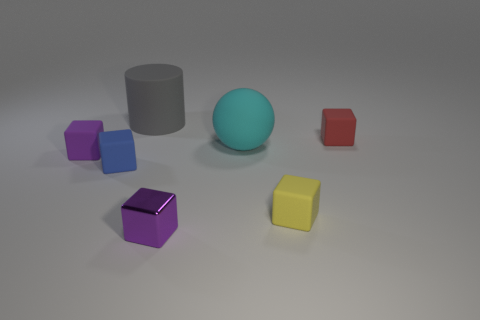Subtract all yellow blocks. How many blocks are left? 4 Subtract all gray blocks. Subtract all green cylinders. How many blocks are left? 5 Add 3 purple shiny cylinders. How many objects exist? 10 Subtract all cylinders. How many objects are left? 6 Subtract 1 red blocks. How many objects are left? 6 Subtract all green shiny cylinders. Subtract all big cyan rubber things. How many objects are left? 6 Add 1 metal objects. How many metal objects are left? 2 Add 6 big blue rubber cylinders. How many big blue rubber cylinders exist? 6 